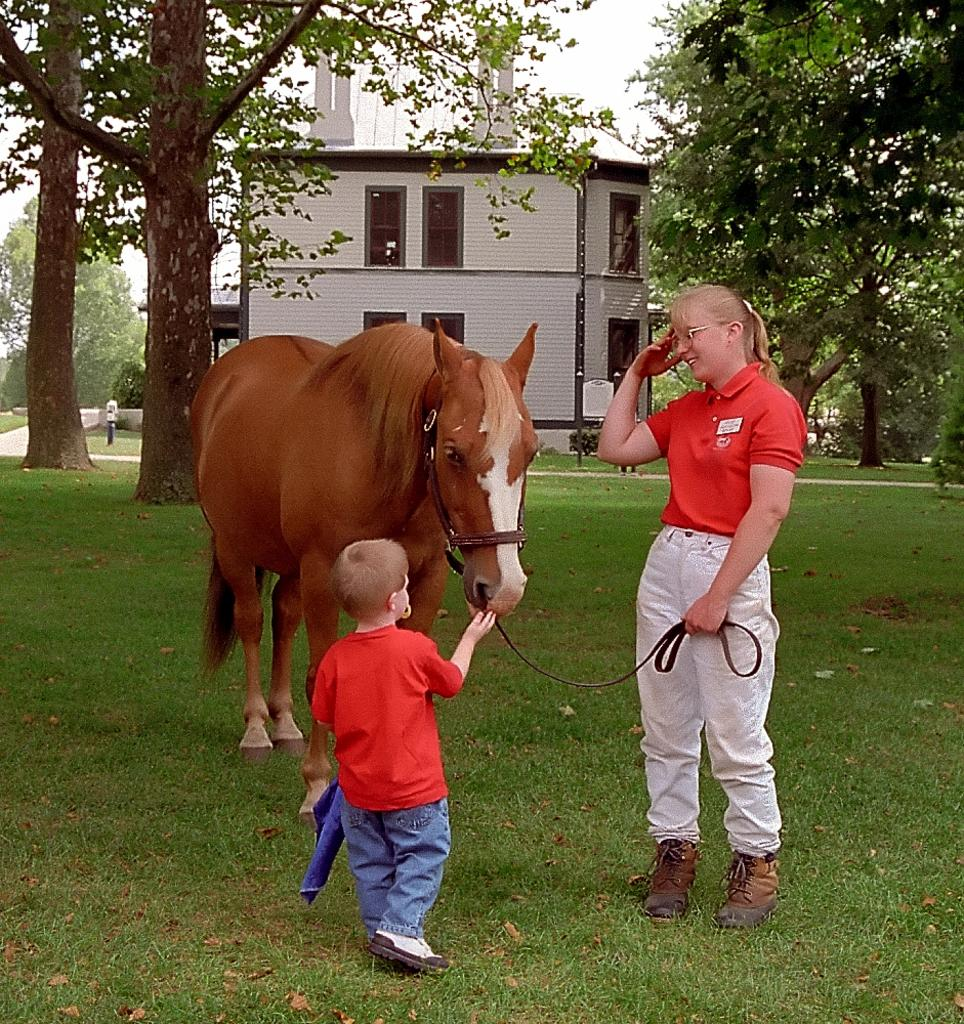Who are the people in the image? There is a lady and a little boy in the image. What is the little boy holding? The little boy is holding a horse. Where is the horse located? The horse is on the grass. What can be seen in the background of the image? There are trees and a house visible in the background. What type of quilt is being used to cover the beds in the image? There are no beds or quilts present in the image. How many baseballs can be seen in the image? There are no baseballs present in the image. 